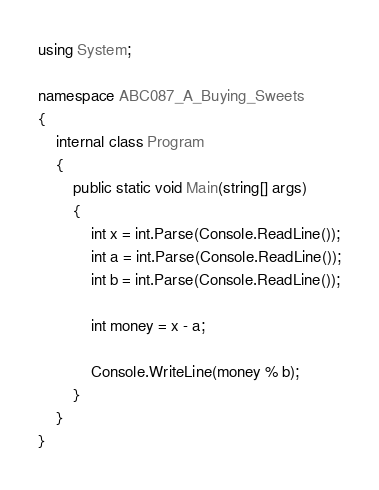<code> <loc_0><loc_0><loc_500><loc_500><_C#_>using System;

namespace ABC087_A_Buying_Sweets
{
	internal class Program
	{
		public static void Main(string[] args)
		{
			int x = int.Parse(Console.ReadLine());
			int a = int.Parse(Console.ReadLine());
			int b = int.Parse(Console.ReadLine());

			int money = x - a;
			
			Console.WriteLine(money % b);
		}
	}
}</code> 